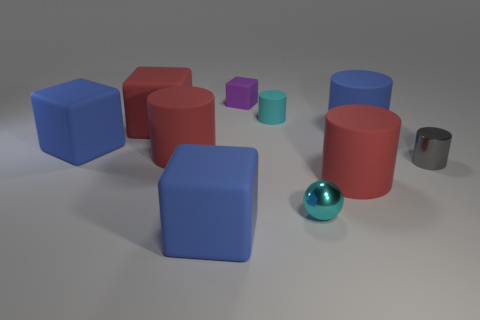Subtract all small shiny cylinders. How many cylinders are left? 4 Subtract all gray cylinders. How many cylinders are left? 4 Subtract all cubes. How many objects are left? 6 Subtract 1 spheres. How many spheres are left? 0 Subtract all brown blocks. How many purple balls are left? 0 Subtract all large cyan objects. Subtract all large blue things. How many objects are left? 7 Add 1 large red matte cylinders. How many large red matte cylinders are left? 3 Add 8 small brown matte spheres. How many small brown matte spheres exist? 8 Subtract 0 blue spheres. How many objects are left? 10 Subtract all purple spheres. Subtract all green cubes. How many spheres are left? 1 